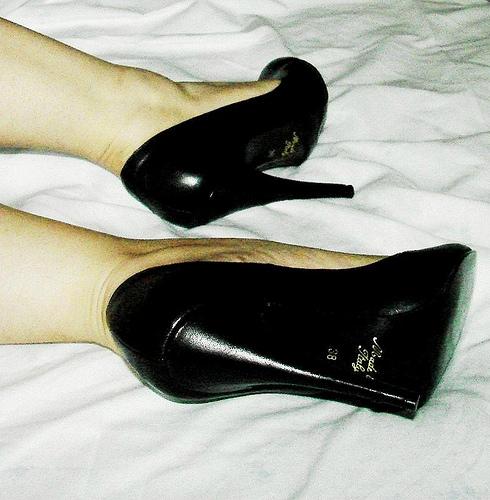Do these look like comfortable shoes?
Concise answer only. No. Is the woman standing?
Quick response, please. No. What type of shoes are these?
Answer briefly. Heels. 